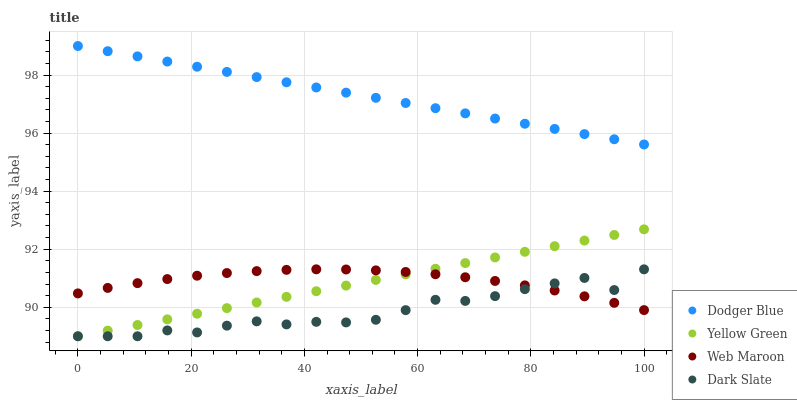Does Dark Slate have the minimum area under the curve?
Answer yes or no. Yes. Does Dodger Blue have the maximum area under the curve?
Answer yes or no. Yes. Does Yellow Green have the minimum area under the curve?
Answer yes or no. No. Does Yellow Green have the maximum area under the curve?
Answer yes or no. No. Is Dodger Blue the smoothest?
Answer yes or no. Yes. Is Dark Slate the roughest?
Answer yes or no. Yes. Is Yellow Green the smoothest?
Answer yes or no. No. Is Yellow Green the roughest?
Answer yes or no. No. Does Yellow Green have the lowest value?
Answer yes or no. Yes. Does Dodger Blue have the lowest value?
Answer yes or no. No. Does Dodger Blue have the highest value?
Answer yes or no. Yes. Does Yellow Green have the highest value?
Answer yes or no. No. Is Yellow Green less than Dodger Blue?
Answer yes or no. Yes. Is Dodger Blue greater than Web Maroon?
Answer yes or no. Yes. Does Web Maroon intersect Yellow Green?
Answer yes or no. Yes. Is Web Maroon less than Yellow Green?
Answer yes or no. No. Is Web Maroon greater than Yellow Green?
Answer yes or no. No. Does Yellow Green intersect Dodger Blue?
Answer yes or no. No. 